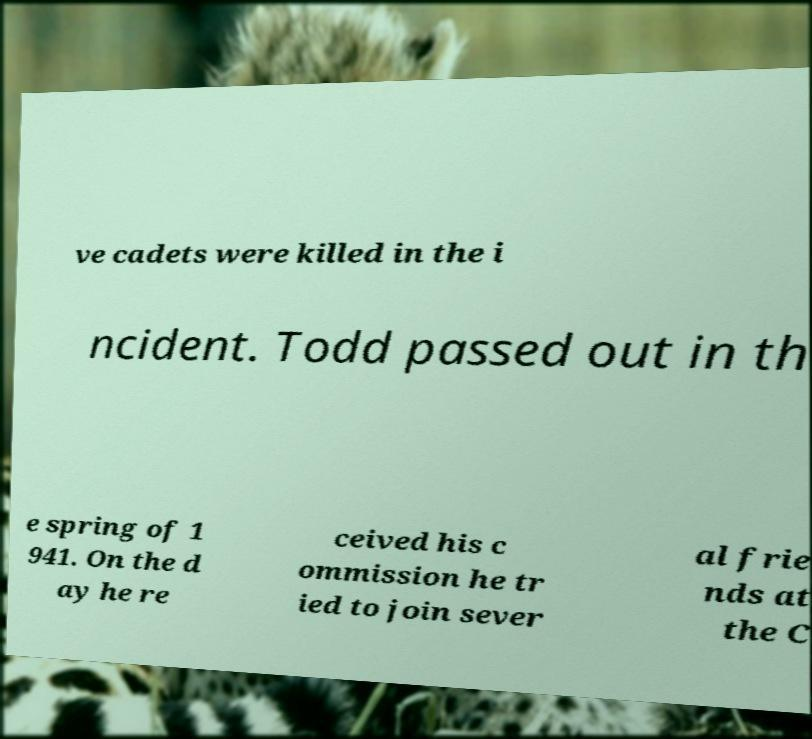Please read and relay the text visible in this image. What does it say? ve cadets were killed in the i ncident. Todd passed out in th e spring of 1 941. On the d ay he re ceived his c ommission he tr ied to join sever al frie nds at the C 